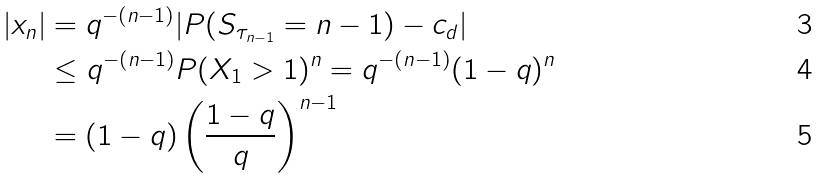Convert formula to latex. <formula><loc_0><loc_0><loc_500><loc_500>| x _ { n } | & = q ^ { - ( n - 1 ) } | P ( S _ { \tau _ { n - 1 } } = n - 1 ) - c _ { d } | \\ & \leq q ^ { - ( n - 1 ) } P ( X _ { 1 } > 1 ) ^ { n } = q ^ { - ( n - 1 ) } ( 1 - q ) ^ { n } \\ & = ( 1 - q ) \left ( \frac { 1 - q } { q } \right ) ^ { n - 1 }</formula> 